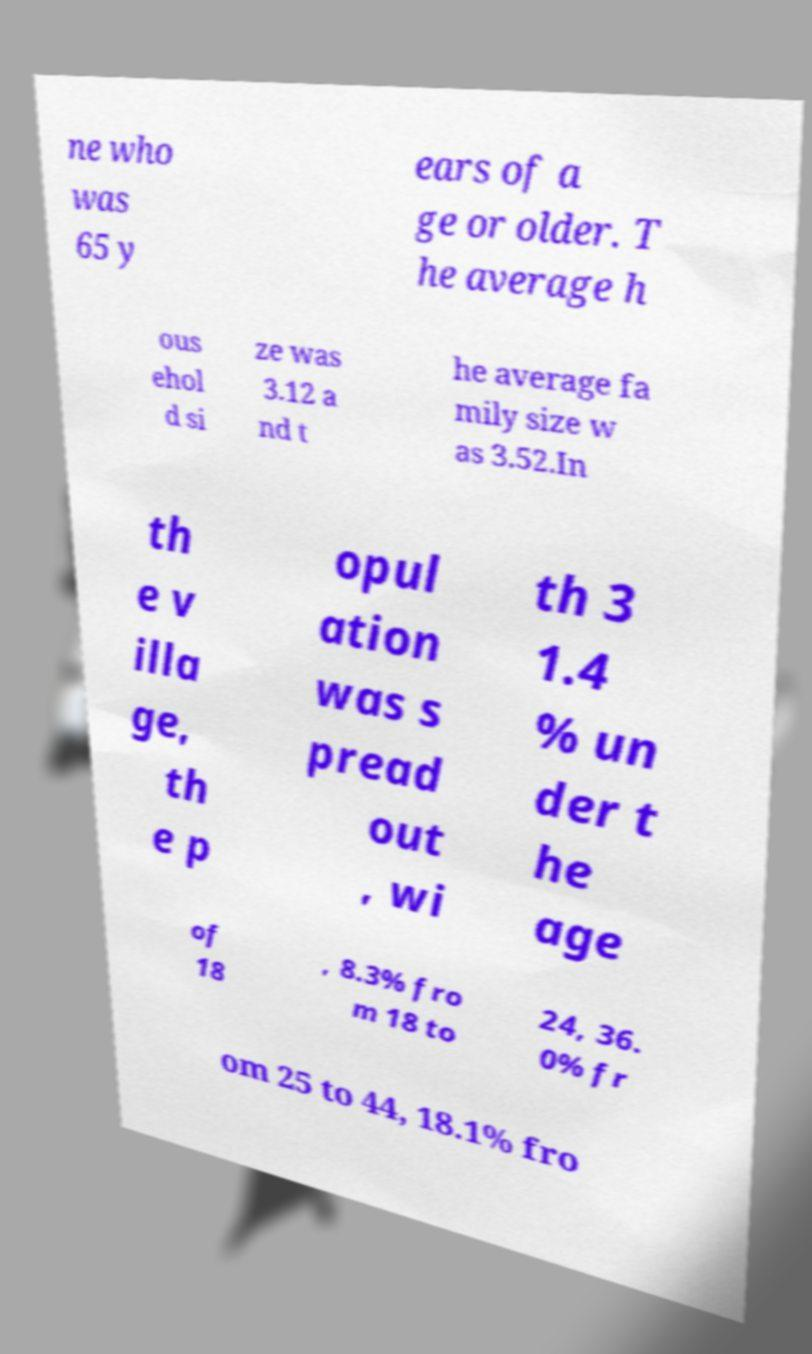Could you assist in decoding the text presented in this image and type it out clearly? ne who was 65 y ears of a ge or older. T he average h ous ehol d si ze was 3.12 a nd t he average fa mily size w as 3.52.In th e v illa ge, th e p opul ation was s pread out , wi th 3 1.4 % un der t he age of 18 , 8.3% fro m 18 to 24, 36. 0% fr om 25 to 44, 18.1% fro 